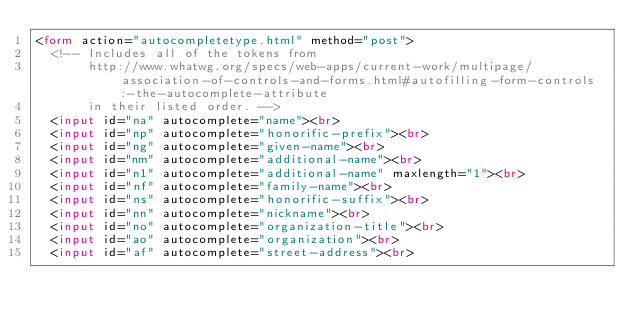Convert code to text. <code><loc_0><loc_0><loc_500><loc_500><_HTML_><form action="autocompletetype.html" method="post">
  <!-- Includes all of the tokens from
       http://www.whatwg.org/specs/web-apps/current-work/multipage/association-of-controls-and-forms.html#autofilling-form-controls:-the-autocomplete-attribute
       in their listed order. -->
  <input id="na" autocomplete="name"><br>
  <input id="np" autocomplete="honorific-prefix"><br>
  <input id="ng" autocomplete="given-name"><br>
  <input id="nm" autocomplete="additional-name"><br>
  <input id="n1" autocomplete="additional-name" maxlength="1"><br>
  <input id="nf" autocomplete="family-name"><br>
  <input id="ns" autocomplete="honorific-suffix"><br>
  <input id="nn" autocomplete="nickname"><br>
  <input id="no" autocomplete="organization-title"><br>
  <input id="ao" autocomplete="organization"><br>
  <input id="af" autocomplete="street-address"><br></code> 